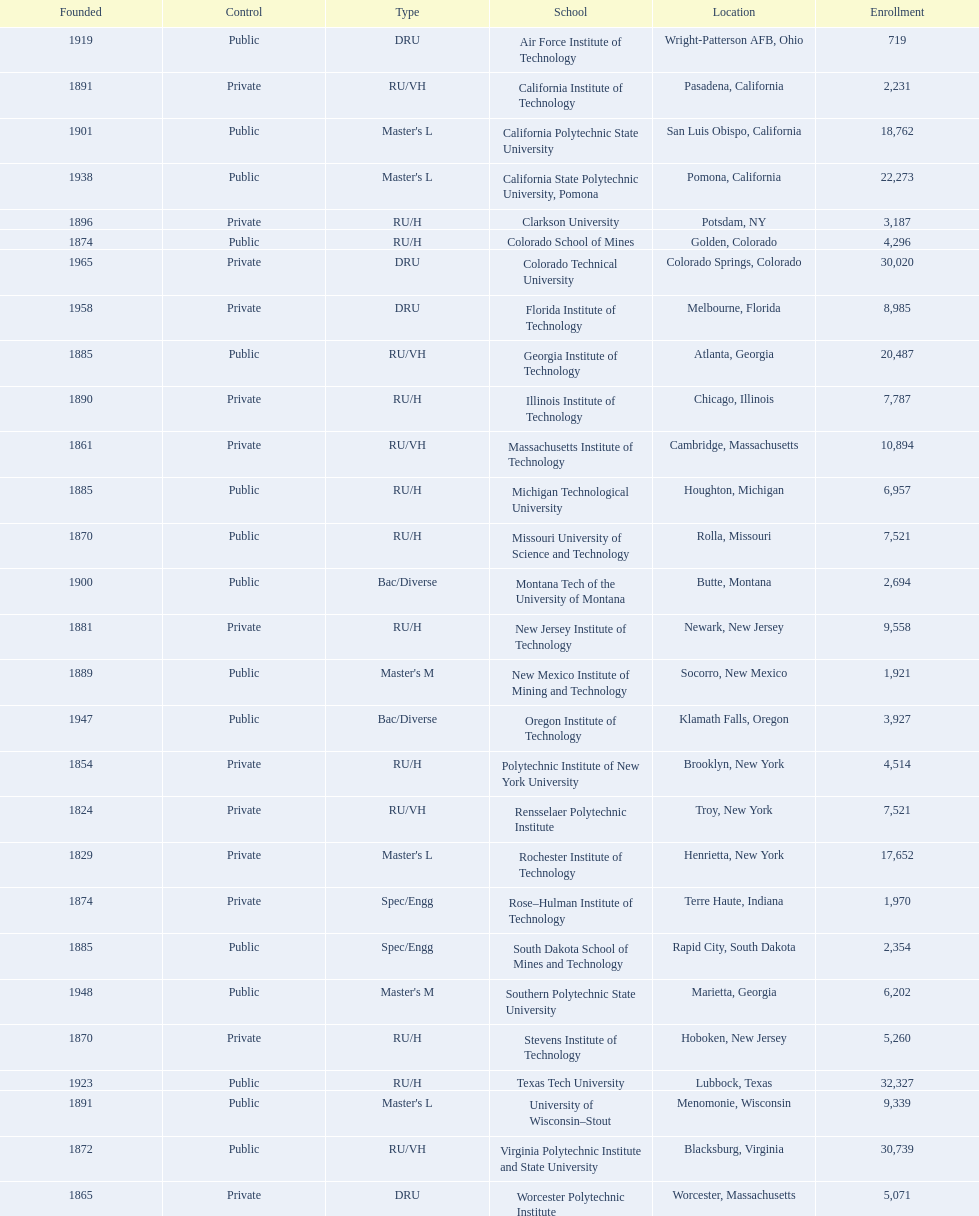Which us technological university has the top enrollment numbers? Texas Tech University. 